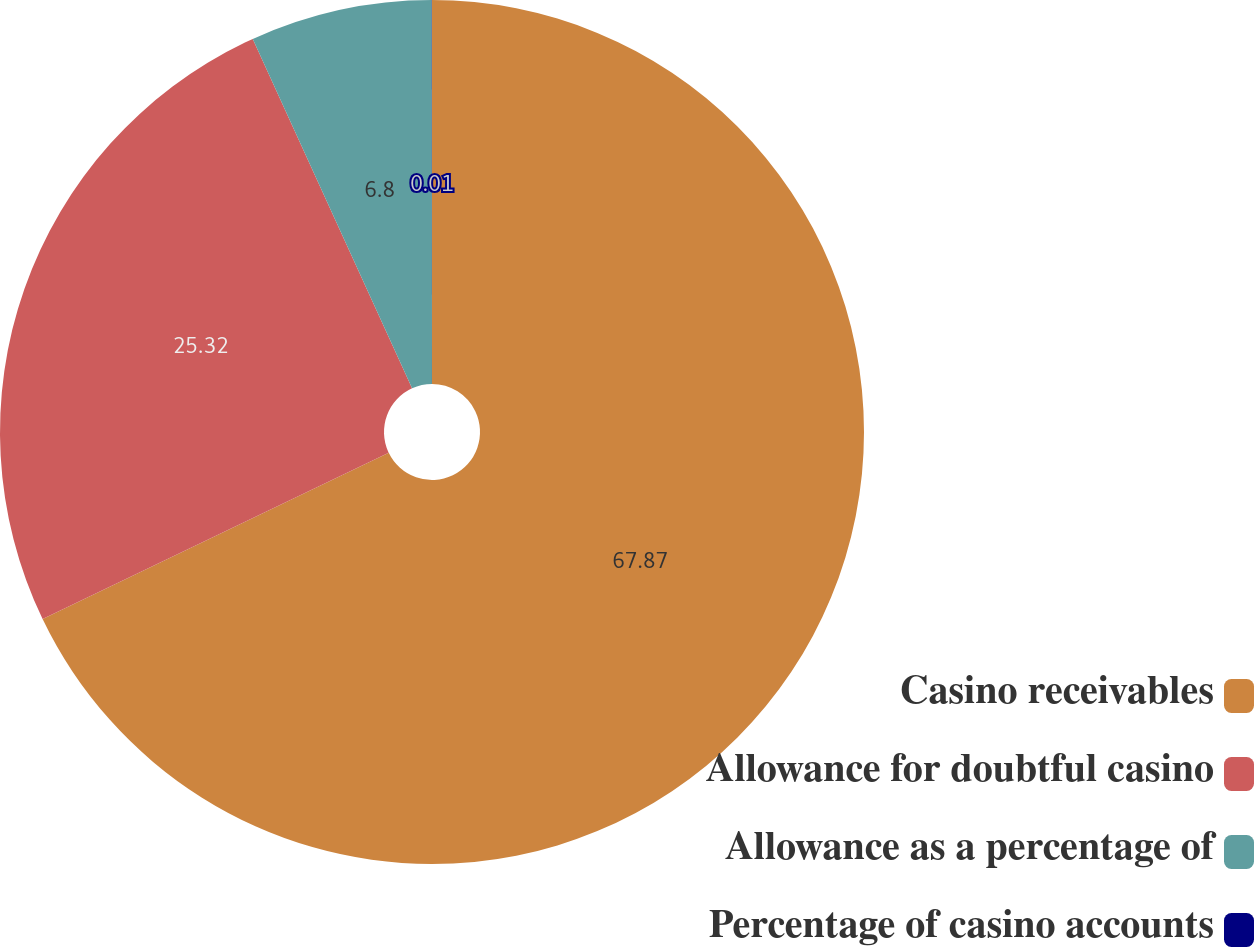Convert chart. <chart><loc_0><loc_0><loc_500><loc_500><pie_chart><fcel>Casino receivables<fcel>Allowance for doubtful casino<fcel>Allowance as a percentage of<fcel>Percentage of casino accounts<nl><fcel>67.88%<fcel>25.32%<fcel>6.8%<fcel>0.01%<nl></chart> 